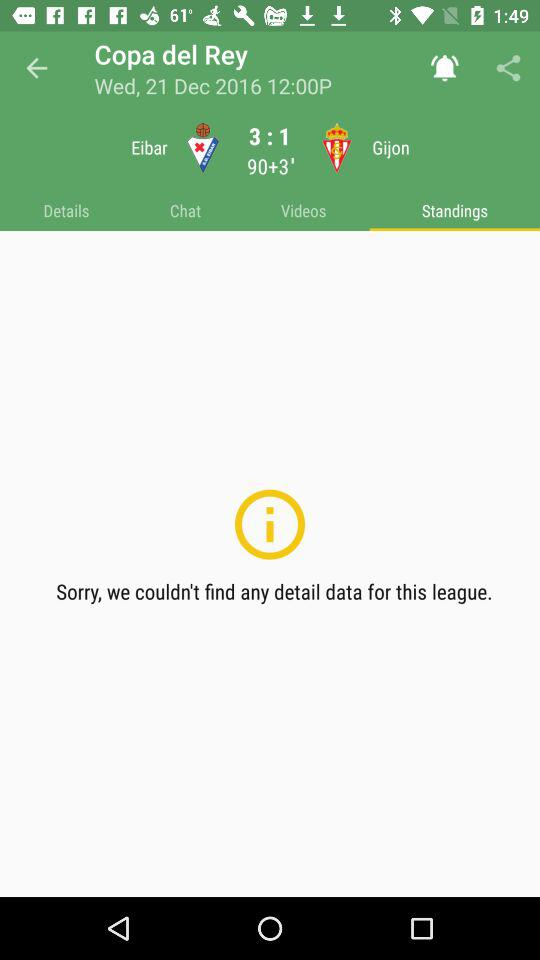What is the score for Ingolstadt vs Freiburg? The score is 0:2. 